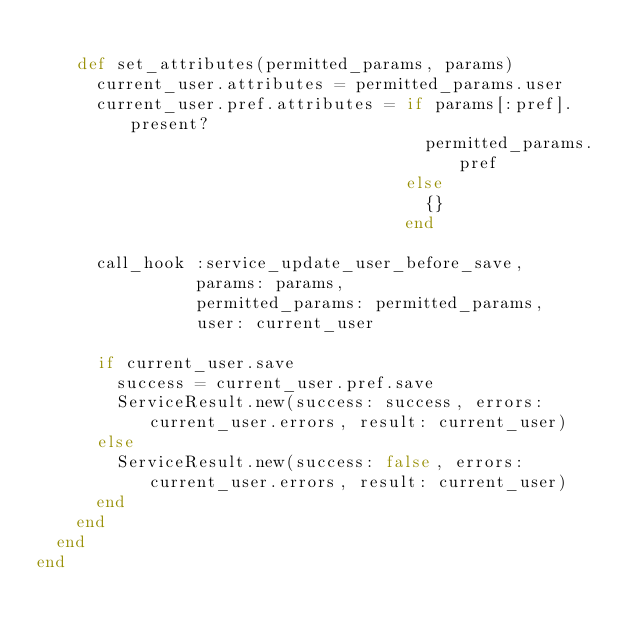Convert code to text. <code><loc_0><loc_0><loc_500><loc_500><_Ruby_>
    def set_attributes(permitted_params, params)
      current_user.attributes = permitted_params.user
      current_user.pref.attributes = if params[:pref].present?
                                       permitted_params.pref
                                     else
                                       {}
                                     end

      call_hook :service_update_user_before_save,
                params: params,
                permitted_params: permitted_params,
                user: current_user

      if current_user.save
        success = current_user.pref.save
        ServiceResult.new(success: success, errors: current_user.errors, result: current_user)
      else
        ServiceResult.new(success: false, errors: current_user.errors, result: current_user)
      end
    end
  end
end
</code> 